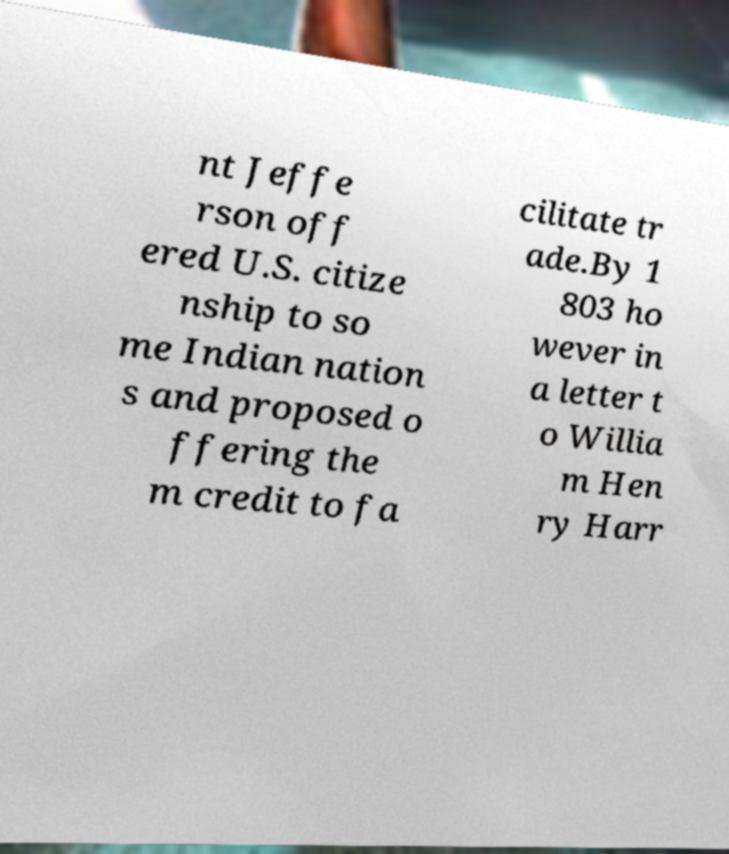Can you read and provide the text displayed in the image?This photo seems to have some interesting text. Can you extract and type it out for me? nt Jeffe rson off ered U.S. citize nship to so me Indian nation s and proposed o ffering the m credit to fa cilitate tr ade.By 1 803 ho wever in a letter t o Willia m Hen ry Harr 